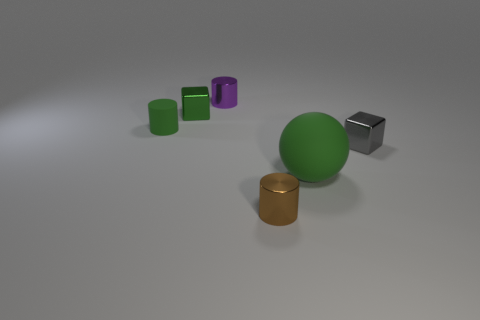What number of other things are made of the same material as the small brown cylinder?
Provide a short and direct response. 3. What number of tiny things are green rubber spheres or cylinders?
Your answer should be very brief. 3. Are there the same number of rubber cylinders that are left of the large green sphere and big gray balls?
Offer a very short reply. No. Is there a purple shiny object behind the metal object that is right of the large green matte ball?
Keep it short and to the point. Yes. What number of other things are there of the same color as the big rubber object?
Your response must be concise. 2. What is the color of the big rubber ball?
Ensure brevity in your answer.  Green. There is a cylinder that is behind the tiny brown shiny object and in front of the green metallic thing; what is its size?
Ensure brevity in your answer.  Small. What number of things are blocks that are behind the gray metal block or brown things?
Your response must be concise. 2. There is a small object that is made of the same material as the large green sphere; what is its shape?
Provide a short and direct response. Cylinder. What shape is the tiny purple thing?
Make the answer very short. Cylinder. 